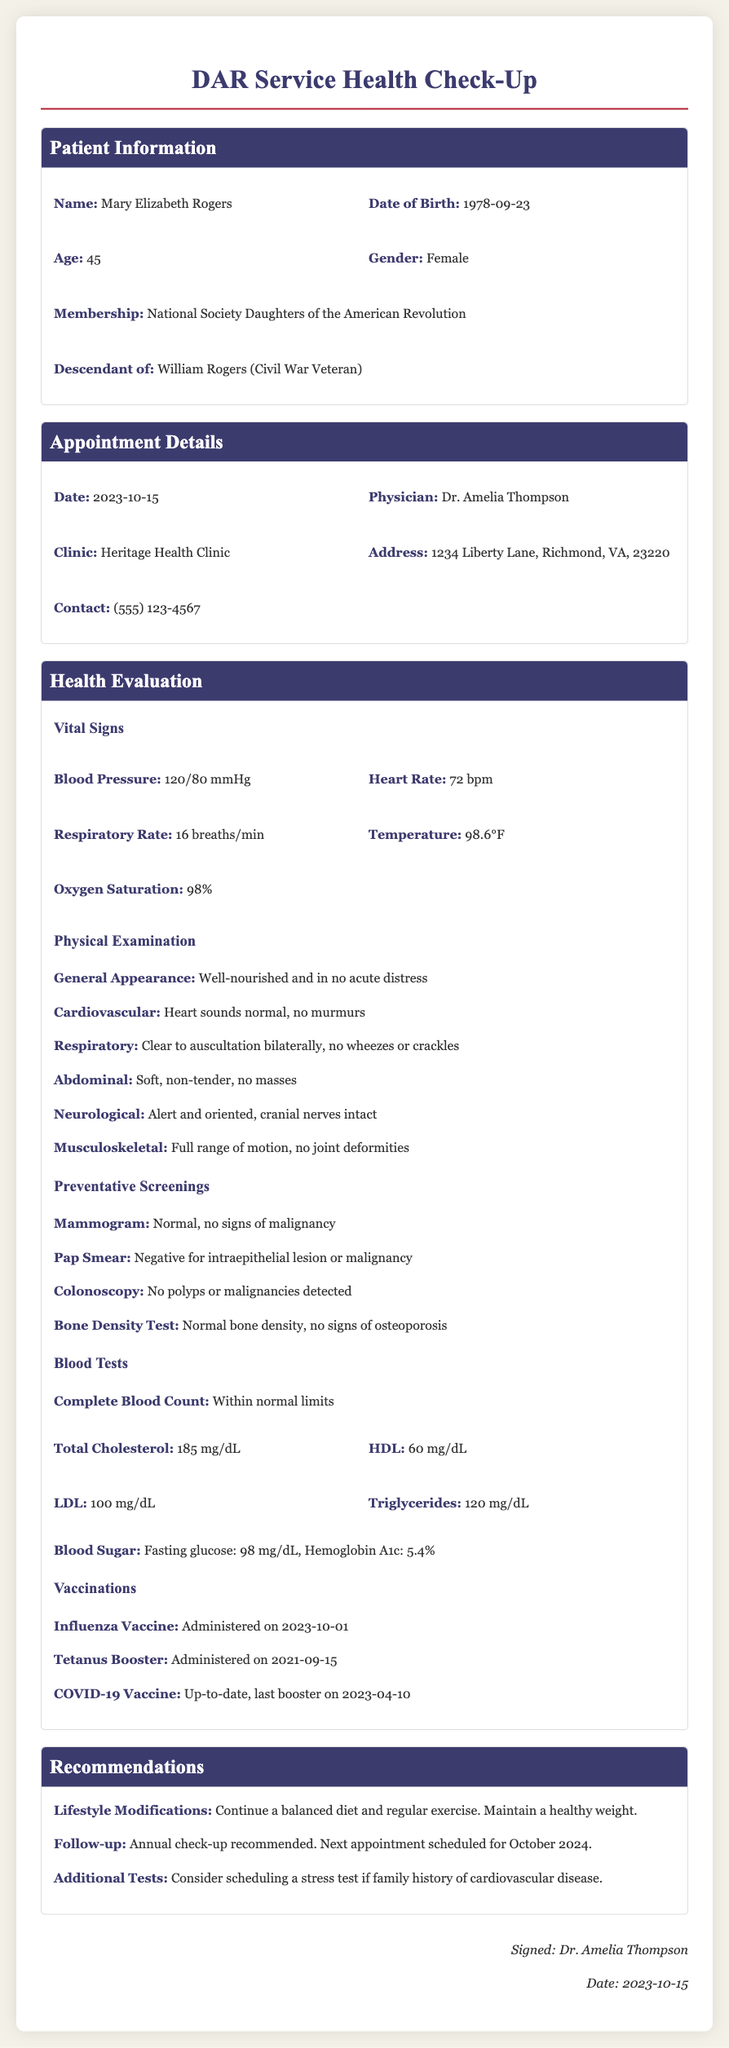What is the name of the patient? The patient's name is listed at the beginning of the document in the patient information section.
Answer: Mary Elizabeth Rogers What is the date of the appointment? The date of the appointment is found in the appointment details section.
Answer: 2023-10-15 Who is the physician that performed the evaluation? The physician's name is included in the appointment details section.
Answer: Dr. Amelia Thompson What was the blood pressure reading? The blood pressure reading is noted under the health evaluation in the vital signs section.
Answer: 120/80 mmHg What were the results of the colonoscopy? The result of the colonoscopy is provided under the preventative screenings section.
Answer: No polyps or malignancies detected What lifestyle modifications are recommended? Recommendations for lifestyle modifications are found in the recommendations section.
Answer: Continue a balanced diet and regular exercise. Maintain a healthy weight When was the influenza vaccine administered? The date of influenza vaccine administration is mentioned in the vaccinations section.
Answer: 2023-10-01 What is the patient's age? The patient's age is stated in the patient information section.
Answer: 45 What follows the recommendation for a stress test? The reasoning for considering additional tests follows the recommendations for lifestyle modifications.
Answer: Consider scheduling a stress test if family history of cardiovascular disease 